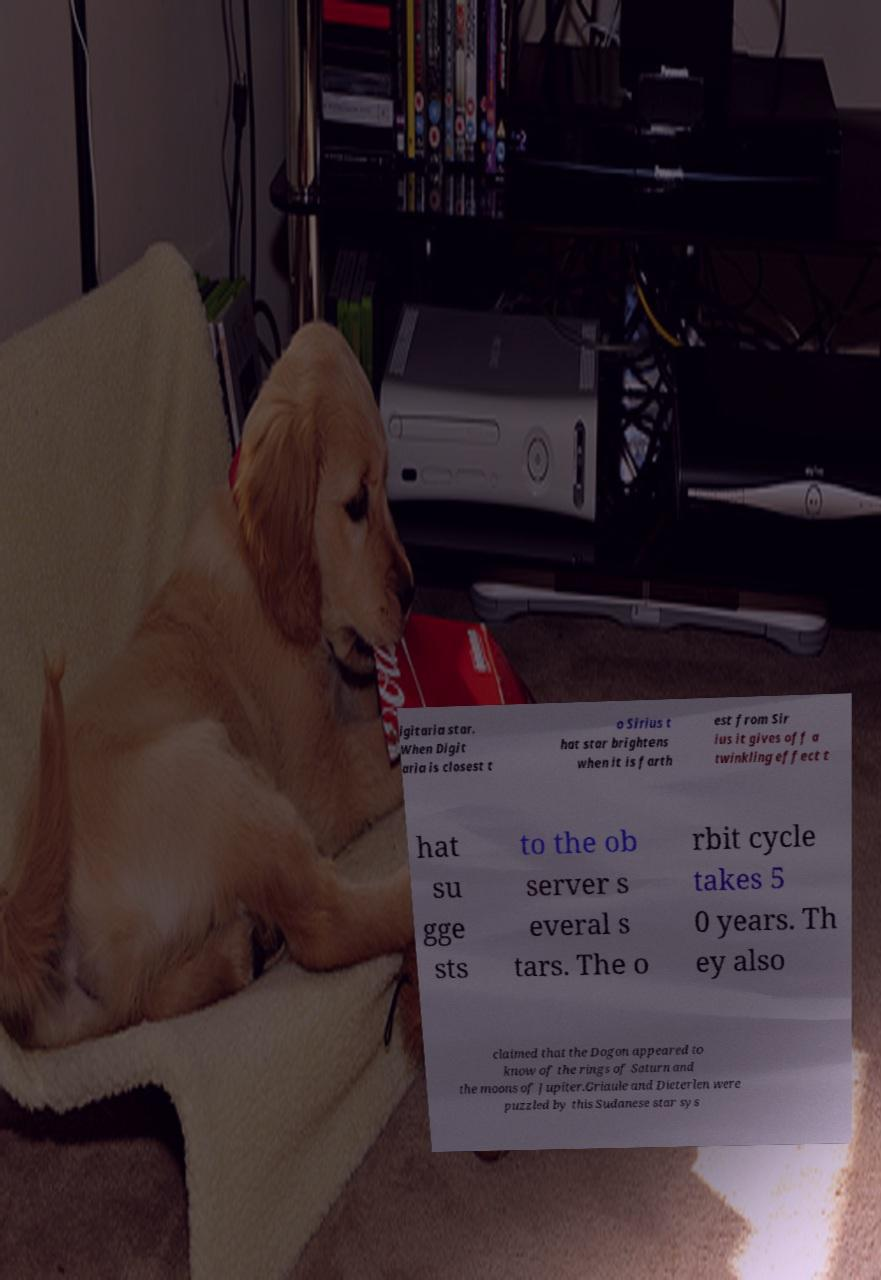I need the written content from this picture converted into text. Can you do that? igitaria star. When Digit aria is closest t o Sirius t hat star brightens when it is farth est from Sir ius it gives off a twinkling effect t hat su gge sts to the ob server s everal s tars. The o rbit cycle takes 5 0 years. Th ey also claimed that the Dogon appeared to know of the rings of Saturn and the moons of Jupiter.Griaule and Dieterlen were puzzled by this Sudanese star sys 